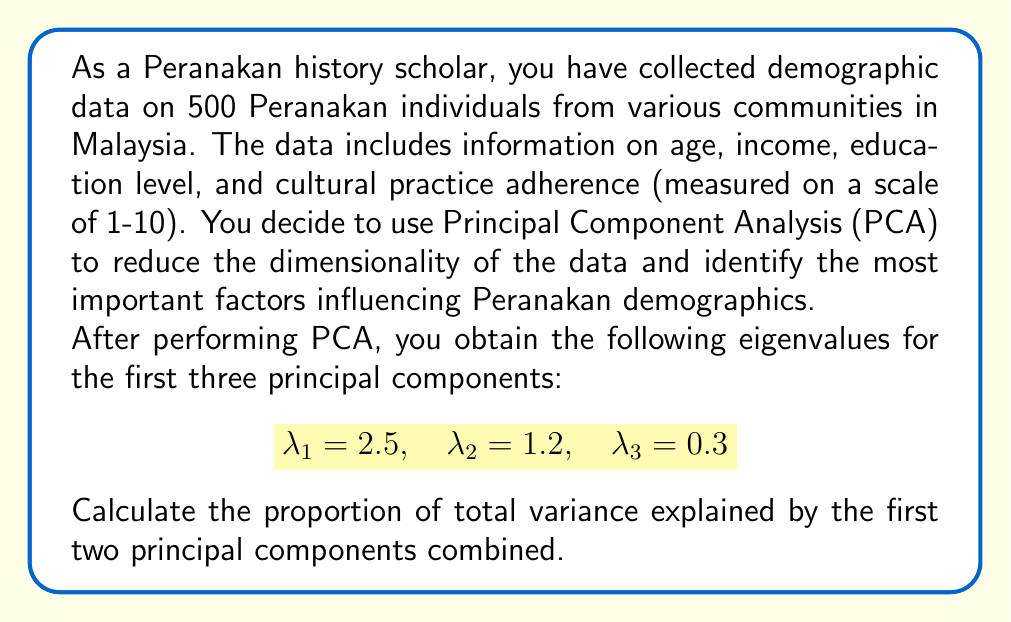Can you answer this question? To solve this problem, we need to follow these steps:

1) First, recall that in PCA, each eigenvalue represents the amount of variance explained by its corresponding principal component.

2) The total variance in the dataset is equal to the sum of all eigenvalues. In this case, we have 4 variables, so the total variance is 4 (as PCA uses standardized variables with unit variance).

3) To calculate the proportion of variance explained by the first two principal components, we need to:
   a) Sum the eigenvalues of the first two components
   b) Divide this sum by the total variance

4) Let's perform the calculation:

   Sum of first two eigenvalues: $2.5 + 1.2 = 3.7$

   Proportion of variance explained:
   
   $$\frac{3.7}{4} = 0.925 \text{ or } 92.5\%$$

5) Therefore, the first two principal components together explain 92.5% of the total variance in the Peranakan demographic data.

This high percentage suggests that these two components capture most of the important information in the dataset, potentially revealing key factors influencing Peranakan demographics in Malaysia.
Answer: 92.5% 